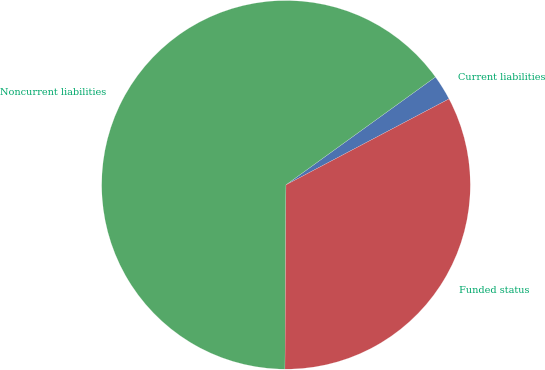Convert chart. <chart><loc_0><loc_0><loc_500><loc_500><pie_chart><fcel>Current liabilities<fcel>Noncurrent liabilities<fcel>Funded status<nl><fcel>2.23%<fcel>64.96%<fcel>32.81%<nl></chart> 